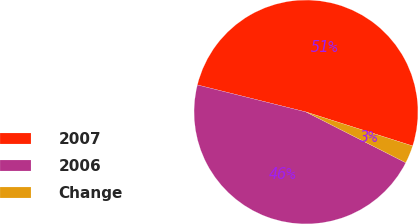Convert chart to OTSL. <chart><loc_0><loc_0><loc_500><loc_500><pie_chart><fcel>2007<fcel>2006<fcel>Change<nl><fcel>51.03%<fcel>46.39%<fcel>2.58%<nl></chart> 